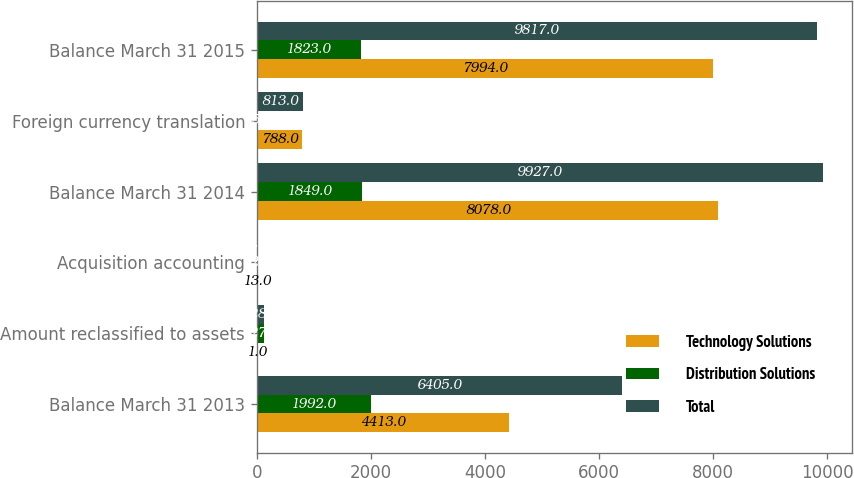<chart> <loc_0><loc_0><loc_500><loc_500><stacked_bar_chart><ecel><fcel>Balance March 31 2013<fcel>Amount reclassified to assets<fcel>Acquisition accounting<fcel>Balance March 31 2014<fcel>Foreign currency translation<fcel>Balance March 31 2015<nl><fcel>Technology Solutions<fcel>4413<fcel>1<fcel>13<fcel>8078<fcel>788<fcel>7994<nl><fcel>Distribution Solutions<fcel>1992<fcel>127<fcel>12<fcel>1849<fcel>25<fcel>1823<nl><fcel>Total<fcel>6405<fcel>128<fcel>1<fcel>9927<fcel>813<fcel>9817<nl></chart> 